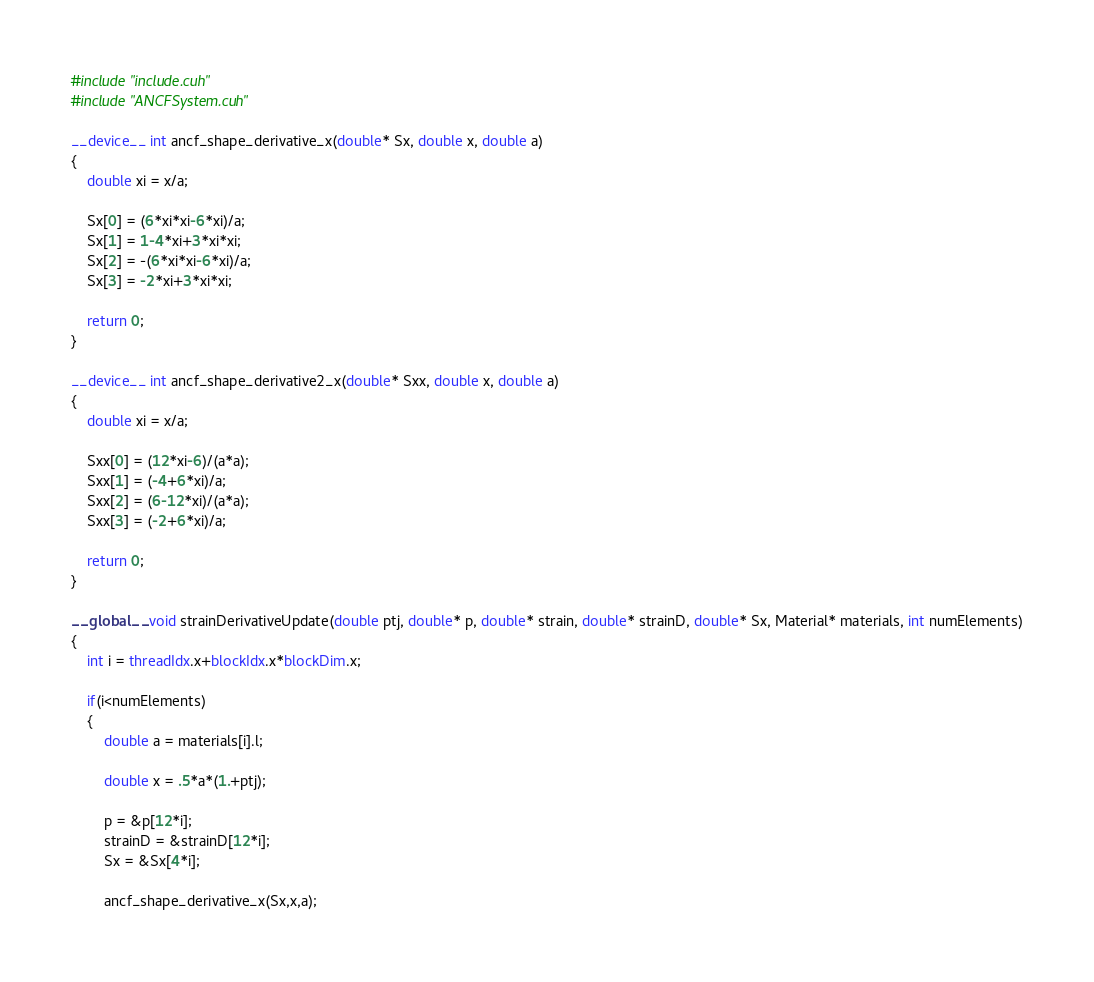<code> <loc_0><loc_0><loc_500><loc_500><_Cuda_>#include "include.cuh"
#include "ANCFSystem.cuh"

__device__ int ancf_shape_derivative_x(double* Sx, double x, double a)
{
	double xi = x/a;

	Sx[0] = (6*xi*xi-6*xi)/a;
	Sx[1] = 1-4*xi+3*xi*xi;
	Sx[2] = -(6*xi*xi-6*xi)/a;
	Sx[3] = -2*xi+3*xi*xi;

	return 0;
}

__device__ int ancf_shape_derivative2_x(double* Sxx, double x, double a)
{
	double xi = x/a;

	Sxx[0] = (12*xi-6)/(a*a);
	Sxx[1] = (-4+6*xi)/a;
	Sxx[2] = (6-12*xi)/(a*a);
	Sxx[3] = (-2+6*xi)/a;

	return 0;
}

__global__ void strainDerivativeUpdate(double ptj, double* p, double* strain, double* strainD, double* Sx, Material* materials, int numElements)
{
	int i = threadIdx.x+blockIdx.x*blockDim.x;

	if(i<numElements)
	{
		double a = materials[i].l;

		double x = .5*a*(1.+ptj);

		p = &p[12*i];
		strainD = &strainD[12*i];
		Sx = &Sx[4*i];

		ancf_shape_derivative_x(Sx,x,a);
</code> 